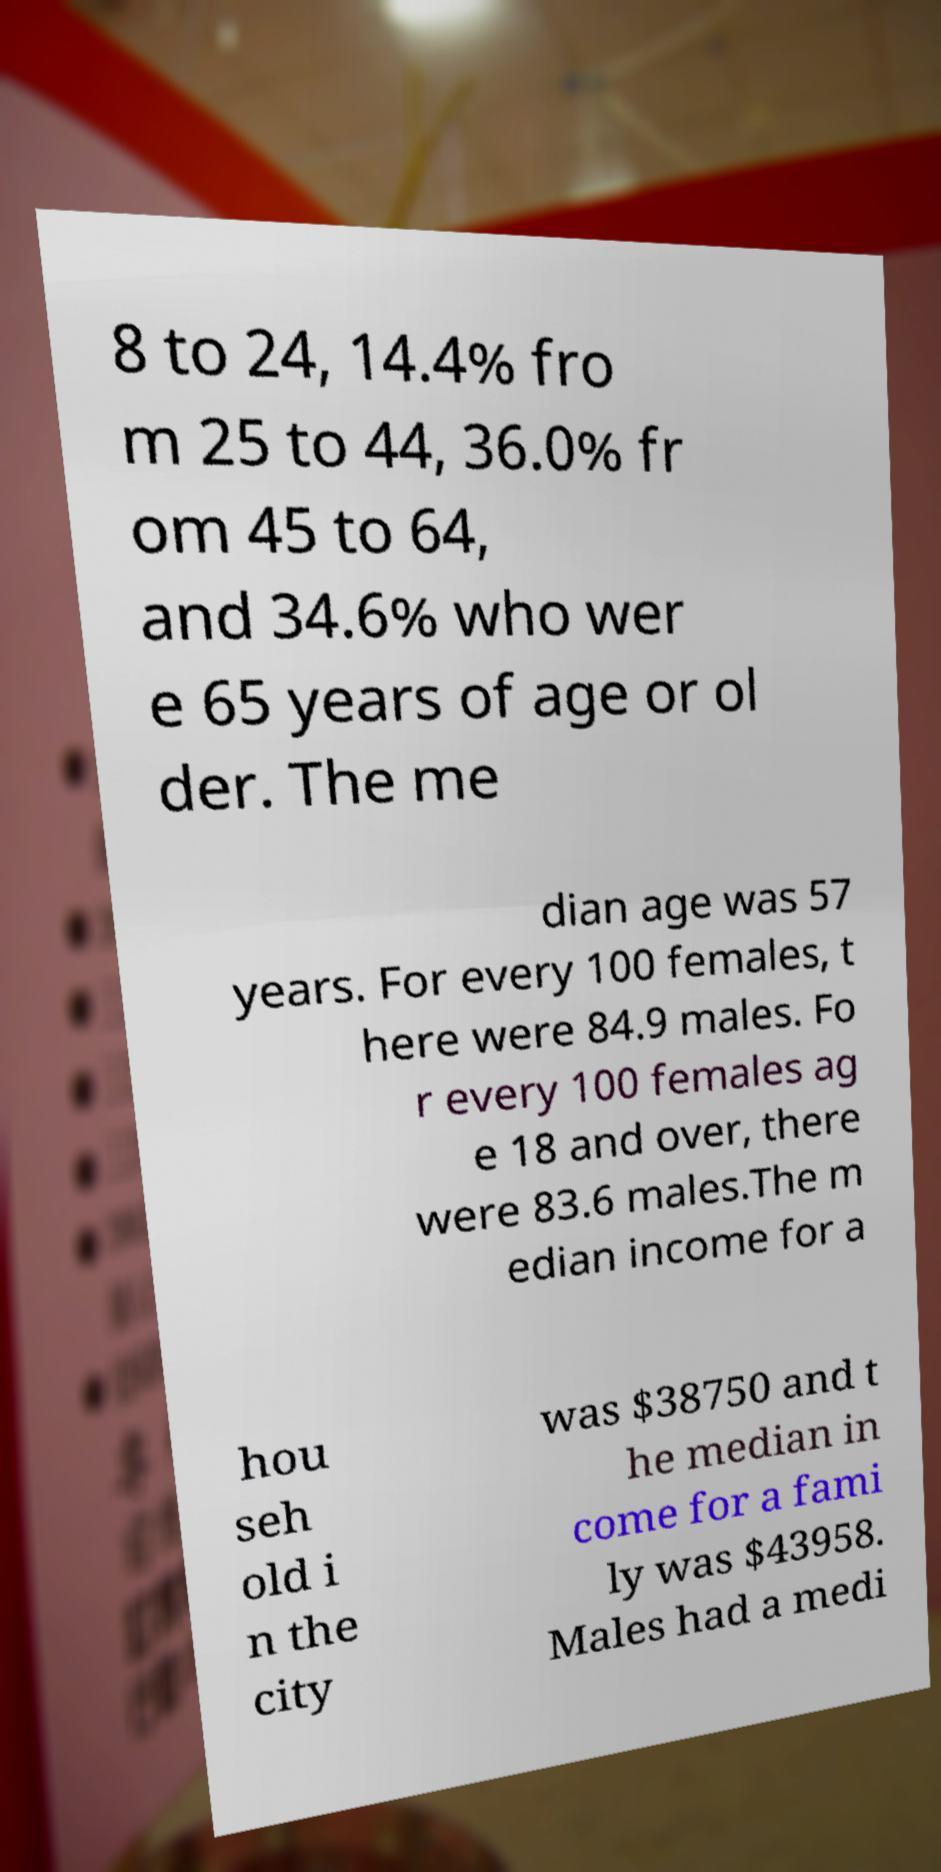Can you read and provide the text displayed in the image?This photo seems to have some interesting text. Can you extract and type it out for me? 8 to 24, 14.4% fro m 25 to 44, 36.0% fr om 45 to 64, and 34.6% who wer e 65 years of age or ol der. The me dian age was 57 years. For every 100 females, t here were 84.9 males. Fo r every 100 females ag e 18 and over, there were 83.6 males.The m edian income for a hou seh old i n the city was $38750 and t he median in come for a fami ly was $43958. Males had a medi 